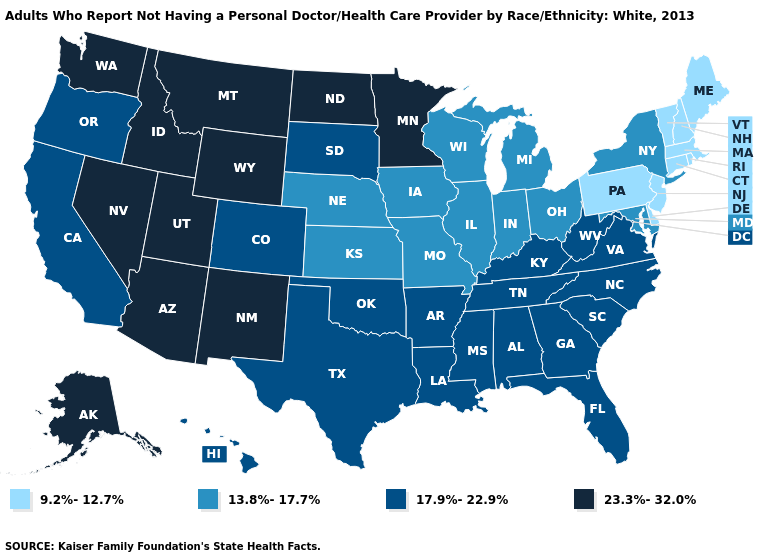Among the states that border Maryland , does West Virginia have the highest value?
Short answer required. Yes. Name the states that have a value in the range 13.8%-17.7%?
Give a very brief answer. Illinois, Indiana, Iowa, Kansas, Maryland, Michigan, Missouri, Nebraska, New York, Ohio, Wisconsin. Does Arizona have a higher value than North Dakota?
Quick response, please. No. Does the map have missing data?
Write a very short answer. No. Name the states that have a value in the range 13.8%-17.7%?
Short answer required. Illinois, Indiana, Iowa, Kansas, Maryland, Michigan, Missouri, Nebraska, New York, Ohio, Wisconsin. Does the first symbol in the legend represent the smallest category?
Keep it brief. Yes. Name the states that have a value in the range 17.9%-22.9%?
Quick response, please. Alabama, Arkansas, California, Colorado, Florida, Georgia, Hawaii, Kentucky, Louisiana, Mississippi, North Carolina, Oklahoma, Oregon, South Carolina, South Dakota, Tennessee, Texas, Virginia, West Virginia. Name the states that have a value in the range 17.9%-22.9%?
Keep it brief. Alabama, Arkansas, California, Colorado, Florida, Georgia, Hawaii, Kentucky, Louisiana, Mississippi, North Carolina, Oklahoma, Oregon, South Carolina, South Dakota, Tennessee, Texas, Virginia, West Virginia. Name the states that have a value in the range 9.2%-12.7%?
Be succinct. Connecticut, Delaware, Maine, Massachusetts, New Hampshire, New Jersey, Pennsylvania, Rhode Island, Vermont. Name the states that have a value in the range 17.9%-22.9%?
Give a very brief answer. Alabama, Arkansas, California, Colorado, Florida, Georgia, Hawaii, Kentucky, Louisiana, Mississippi, North Carolina, Oklahoma, Oregon, South Carolina, South Dakota, Tennessee, Texas, Virginia, West Virginia. What is the value of Iowa?
Write a very short answer. 13.8%-17.7%. What is the highest value in the Northeast ?
Write a very short answer. 13.8%-17.7%. Among the states that border Connecticut , does Rhode Island have the highest value?
Concise answer only. No. Does South Carolina have the highest value in the USA?
Quick response, please. No. 